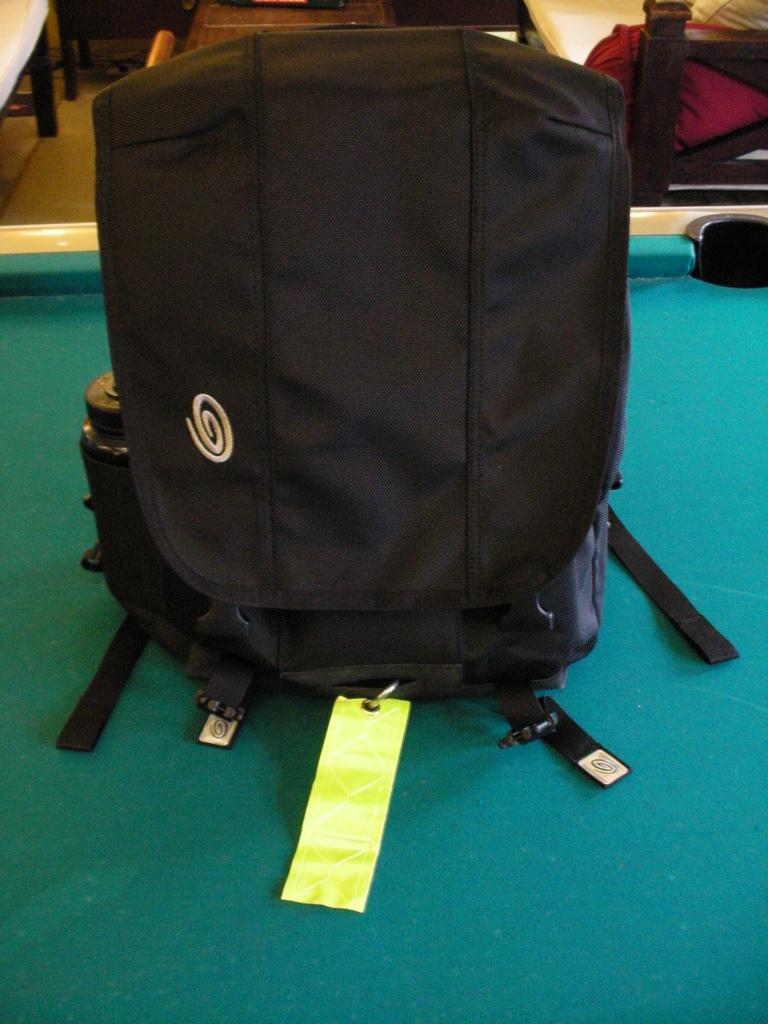What is the main object in the image? There is a billiards table in the image. What else can be seen near the billiards table? There is a black bag beside the billiards table, and a water bottle beside the black bag. Where is the bench located in the image? The bench is in the top right corner of the image. What is on the bench? The bench contains a pillow. What type of view can be seen from the bench in the image? There is no view visible from the bench in the image; it is focused on the billiards table and nearby objects. 